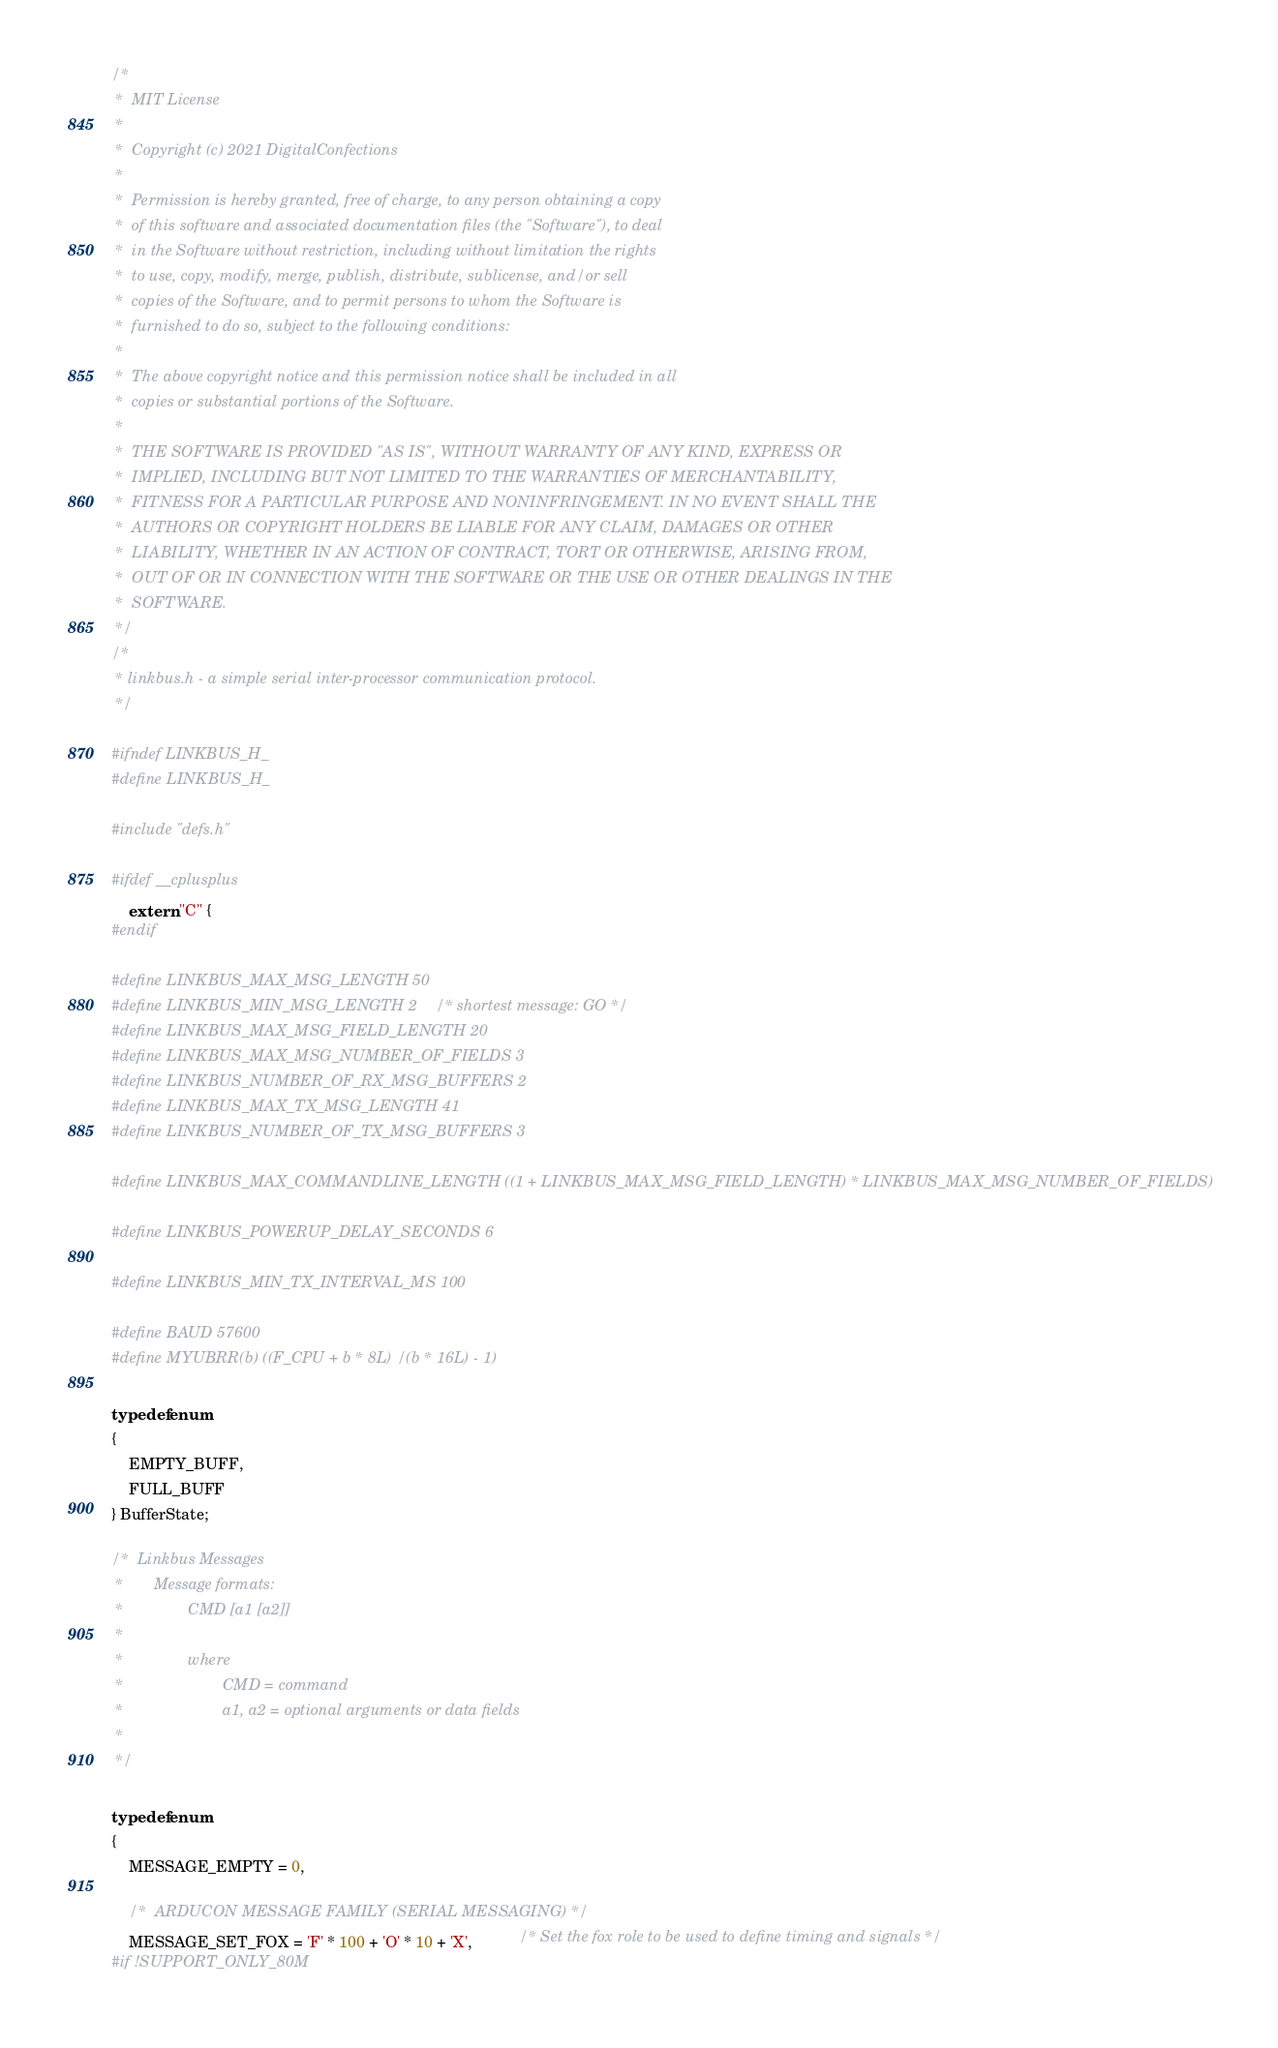<code> <loc_0><loc_0><loc_500><loc_500><_C_>/*
 *  MIT License
 *
 *  Copyright (c) 2021 DigitalConfections
 *
 *  Permission is hereby granted, free of charge, to any person obtaining a copy
 *  of this software and associated documentation files (the "Software"), to deal
 *  in the Software without restriction, including without limitation the rights
 *  to use, copy, modify, merge, publish, distribute, sublicense, and/or sell
 *  copies of the Software, and to permit persons to whom the Software is
 *  furnished to do so, subject to the following conditions:
 *
 *  The above copyright notice and this permission notice shall be included in all
 *  copies or substantial portions of the Software.
 *
 *  THE SOFTWARE IS PROVIDED "AS IS", WITHOUT WARRANTY OF ANY KIND, EXPRESS OR
 *  IMPLIED, INCLUDING BUT NOT LIMITED TO THE WARRANTIES OF MERCHANTABILITY,
 *  FITNESS FOR A PARTICULAR PURPOSE AND NONINFRINGEMENT. IN NO EVENT SHALL THE
 *  AUTHORS OR COPYRIGHT HOLDERS BE LIABLE FOR ANY CLAIM, DAMAGES OR OTHER
 *  LIABILITY, WHETHER IN AN ACTION OF CONTRACT, TORT OR OTHERWISE, ARISING FROM,
 *  OUT OF OR IN CONNECTION WITH THE SOFTWARE OR THE USE OR OTHER DEALINGS IN THE
 *  SOFTWARE.
 */
/*
 * linkbus.h - a simple serial inter-processor communication protocol.
 */

#ifndef LINKBUS_H_
#define LINKBUS_H_

#include "defs.h"

#ifdef __cplusplus
	extern "C" {
#endif

#define LINKBUS_MAX_MSG_LENGTH 50
#define LINKBUS_MIN_MSG_LENGTH 2    /* shortest message: GO */
#define LINKBUS_MAX_MSG_FIELD_LENGTH 20
#define LINKBUS_MAX_MSG_NUMBER_OF_FIELDS 3
#define LINKBUS_NUMBER_OF_RX_MSG_BUFFERS 2
#define LINKBUS_MAX_TX_MSG_LENGTH 41
#define LINKBUS_NUMBER_OF_TX_MSG_BUFFERS 3

#define LINKBUS_MAX_COMMANDLINE_LENGTH ((1 + LINKBUS_MAX_MSG_FIELD_LENGTH) * LINKBUS_MAX_MSG_NUMBER_OF_FIELDS)

#define LINKBUS_POWERUP_DELAY_SECONDS 6

#define LINKBUS_MIN_TX_INTERVAL_MS 100

#define BAUD 57600
#define MYUBRR(b) ((F_CPU + b * 8L) / (b * 16L) - 1)

typedef enum
{
	EMPTY_BUFF,
	FULL_BUFF
} BufferState;

/*  Linkbus Messages
 *       Message formats:
 *               CMD [a1 [a2]]
 *
 *               where
 *                       CMD = command
 *                       a1, a2 = optional arguments or data fields
 *
 */

typedef enum
{
	MESSAGE_EMPTY = 0,

	/*	ARDUCON MESSAGE FAMILY (SERIAL MESSAGING) */
	MESSAGE_SET_FOX = 'F' * 100 + 'O' * 10 + 'X',           /* Set the fox role to be used to define timing and signals */
#if !SUPPORT_ONLY_80M</code> 